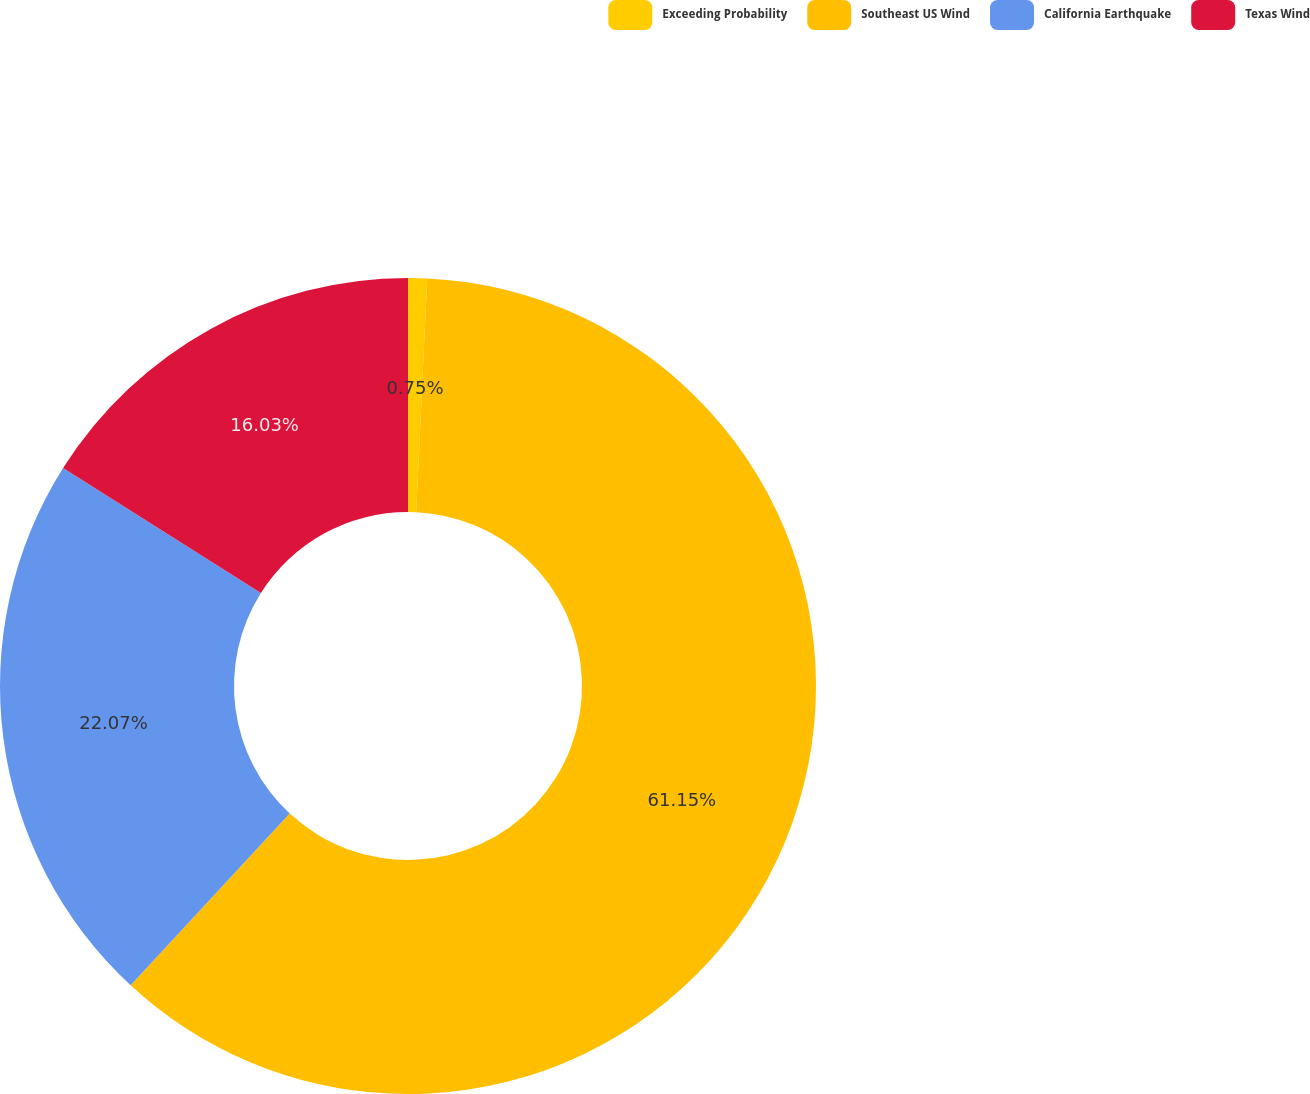Convert chart. <chart><loc_0><loc_0><loc_500><loc_500><pie_chart><fcel>Exceeding Probability<fcel>Southeast US Wind<fcel>California Earthquake<fcel>Texas Wind<nl><fcel>0.75%<fcel>61.14%<fcel>22.07%<fcel>16.03%<nl></chart> 